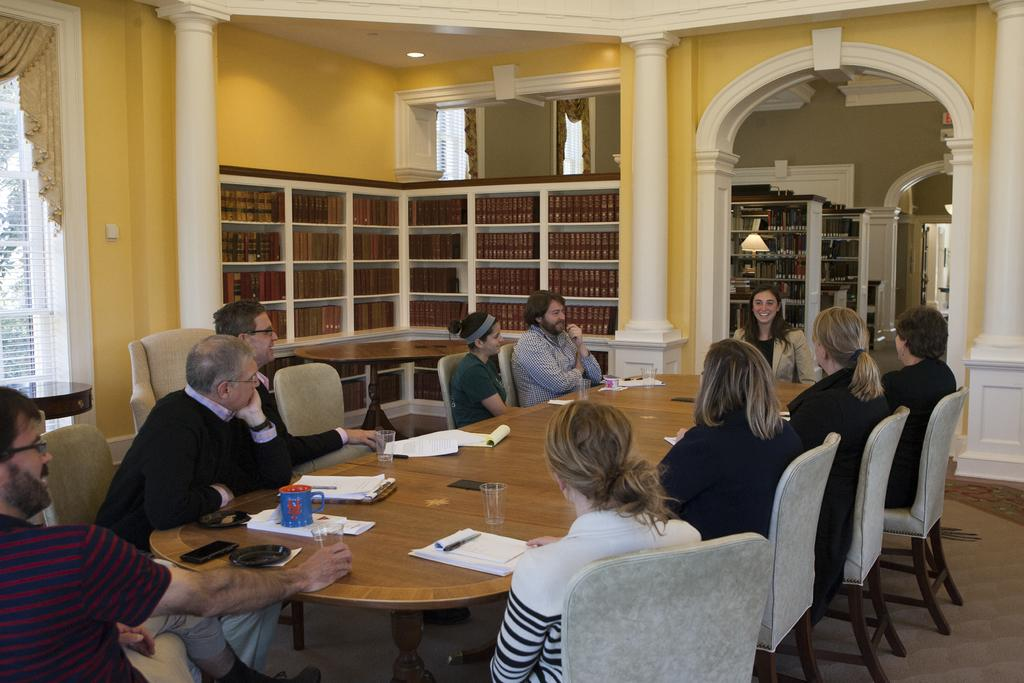What are the people in the image doing? The persons in the image are sitting on chairs. What can be seen on the table in the image? There is a cup, a mobile, a valet, a paper, a pen, and a glass on the table. What is located at the back side of the image? There is a book rack and a lamp at the back side. What type of attraction can be seen in the image? There is no attraction present in the image; it features persons sitting on chairs, a table with various items, and a book rack and lamp at the back side. How many pizzas are visible on the table in the image? There are no pizzas present on the table in the image. 